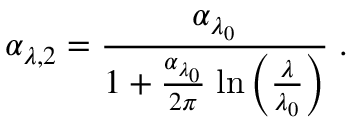Convert formula to latex. <formula><loc_0><loc_0><loc_500><loc_500>\alpha _ { \lambda , 2 } = \frac { \alpha _ { \lambda _ { 0 } } } { 1 + \frac { \alpha _ { \lambda _ { 0 } } } { 2 \pi } \, \ln \left ( \frac { \lambda } { \lambda _ { 0 } } \right ) } \, .</formula> 